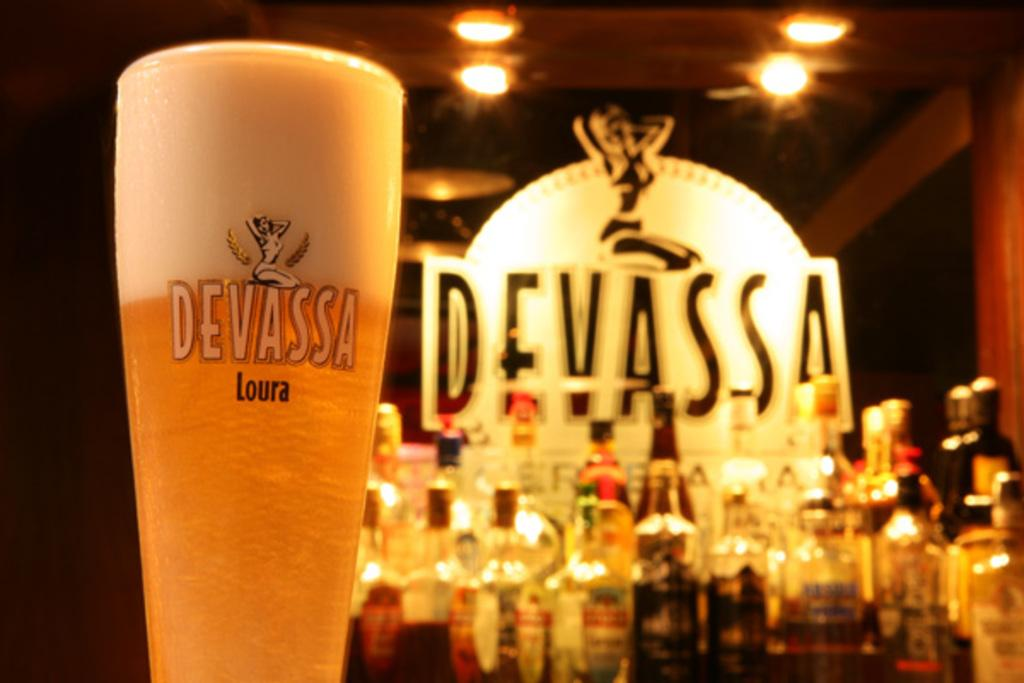<image>
Relay a brief, clear account of the picture shown. the word Devassa that is on a sign 